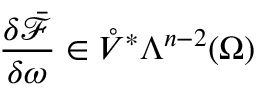Convert formula to latex. <formula><loc_0><loc_0><loc_500><loc_500>\frac { \delta \bar { \mathcal { F } } } { \delta \omega } \in \mathring { V } ^ { \ast } \Lambda ^ { n - 2 } ( \Omega )</formula> 